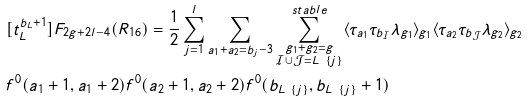<formula> <loc_0><loc_0><loc_500><loc_500>& [ t _ { L } ^ { b _ { L } + 1 } ] F _ { 2 g + 2 l - 4 } ( R _ { 1 6 } ) = \frac { 1 } { 2 } \sum _ { j = 1 } ^ { l } \sum _ { a _ { 1 } + a _ { 2 } = b _ { j } - 3 } \sum _ { \substack { g _ { 1 } + g _ { 2 } = g \\ \mathcal { I } \cup \mathcal { J } = L \ \{ j \} } } ^ { s t a b l e } \langle \tau _ { a _ { 1 } } \tau _ { b _ { \mathcal { I } } } \lambda _ { g _ { 1 } } \rangle _ { g _ { 1 } } \langle \tau _ { a _ { 2 } } \tau _ { b _ { \mathcal { J } } } \lambda _ { g _ { 2 } } \rangle _ { g _ { 2 } } \\ & f ^ { 0 } ( a _ { 1 } + 1 , a _ { 1 } + 2 ) f ^ { 0 } ( a _ { 2 } + 1 , a _ { 2 } + 2 ) f ^ { 0 } ( b _ { L \ \{ j \} } , b _ { L \ \{ j \} } + 1 )</formula> 